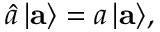<formula> <loc_0><loc_0><loc_500><loc_500>\hat { a } \, | { a } \rangle = a \, | { a } \rangle ,</formula> 